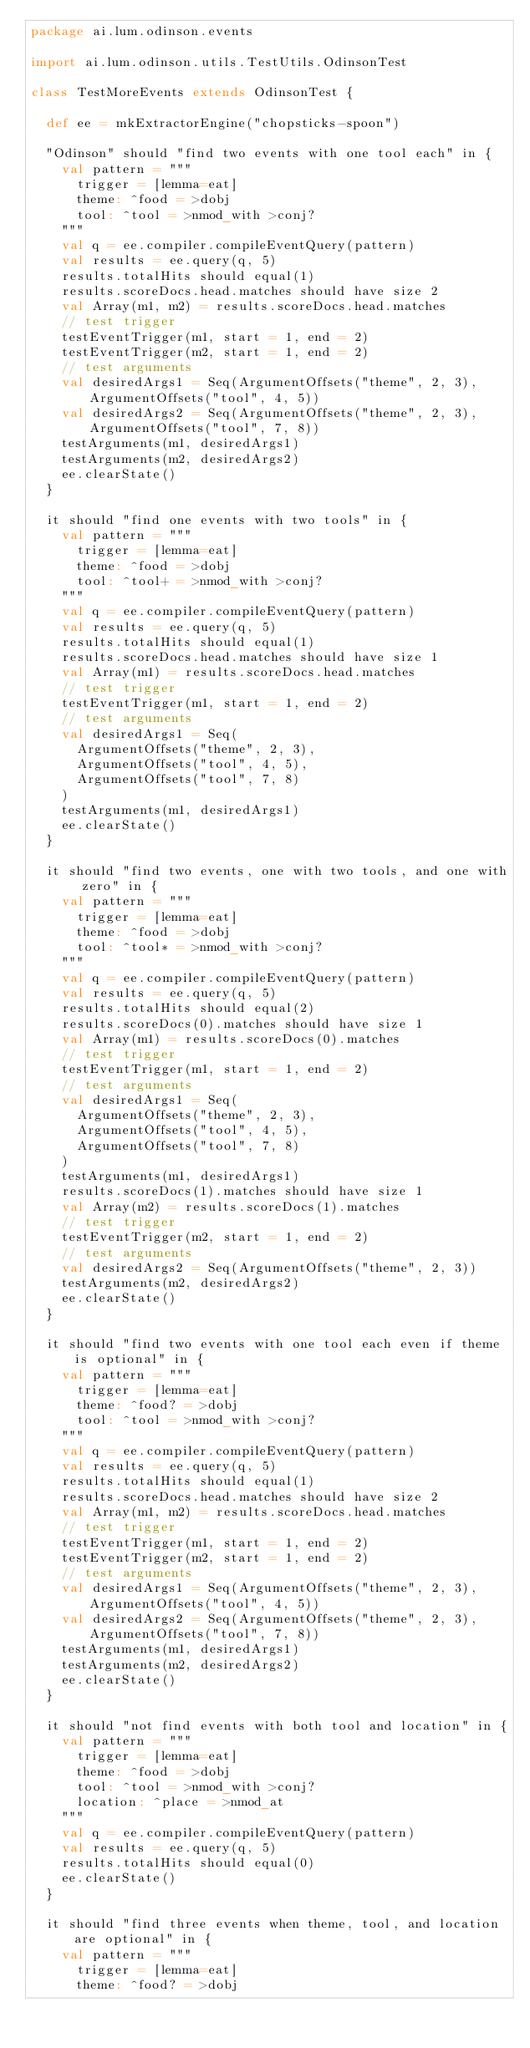<code> <loc_0><loc_0><loc_500><loc_500><_Scala_>package ai.lum.odinson.events

import ai.lum.odinson.utils.TestUtils.OdinsonTest

class TestMoreEvents extends OdinsonTest {

  def ee = mkExtractorEngine("chopsticks-spoon")

  "Odinson" should "find two events with one tool each" in {
    val pattern = """
      trigger = [lemma=eat]
      theme: ^food = >dobj
      tool: ^tool = >nmod_with >conj?
    """
    val q = ee.compiler.compileEventQuery(pattern)
    val results = ee.query(q, 5)
    results.totalHits should equal(1)
    results.scoreDocs.head.matches should have size 2
    val Array(m1, m2) = results.scoreDocs.head.matches
    // test trigger
    testEventTrigger(m1, start = 1, end = 2)
    testEventTrigger(m2, start = 1, end = 2)
    // test arguments
    val desiredArgs1 = Seq(ArgumentOffsets("theme", 2, 3), ArgumentOffsets("tool", 4, 5))
    val desiredArgs2 = Seq(ArgumentOffsets("theme", 2, 3), ArgumentOffsets("tool", 7, 8))
    testArguments(m1, desiredArgs1)
    testArguments(m2, desiredArgs2)
    ee.clearState()
  }

  it should "find one events with two tools" in {
    val pattern = """
      trigger = [lemma=eat]
      theme: ^food = >dobj
      tool: ^tool+ = >nmod_with >conj?
    """
    val q = ee.compiler.compileEventQuery(pattern)
    val results = ee.query(q, 5)
    results.totalHits should equal(1)
    results.scoreDocs.head.matches should have size 1
    val Array(m1) = results.scoreDocs.head.matches
    // test trigger
    testEventTrigger(m1, start = 1, end = 2)
    // test arguments
    val desiredArgs1 = Seq(
      ArgumentOffsets("theme", 2, 3),
      ArgumentOffsets("tool", 4, 5),
      ArgumentOffsets("tool", 7, 8)
    )
    testArguments(m1, desiredArgs1)
    ee.clearState()
  }

  it should "find two events, one with two tools, and one with zero" in {
    val pattern = """
      trigger = [lemma=eat]
      theme: ^food = >dobj
      tool: ^tool* = >nmod_with >conj?
    """
    val q = ee.compiler.compileEventQuery(pattern)
    val results = ee.query(q, 5)
    results.totalHits should equal(2)
    results.scoreDocs(0).matches should have size 1
    val Array(m1) = results.scoreDocs(0).matches
    // test trigger
    testEventTrigger(m1, start = 1, end = 2)
    // test arguments
    val desiredArgs1 = Seq(
      ArgumentOffsets("theme", 2, 3),
      ArgumentOffsets("tool", 4, 5),
      ArgumentOffsets("tool", 7, 8)
    )
    testArguments(m1, desiredArgs1)
    results.scoreDocs(1).matches should have size 1
    val Array(m2) = results.scoreDocs(1).matches
    // test trigger
    testEventTrigger(m2, start = 1, end = 2)
    // test arguments
    val desiredArgs2 = Seq(ArgumentOffsets("theme", 2, 3))
    testArguments(m2, desiredArgs2)
    ee.clearState()
  }

  it should "find two events with one tool each even if theme is optional" in {
    val pattern = """
      trigger = [lemma=eat]
      theme: ^food? = >dobj
      tool: ^tool = >nmod_with >conj?
    """
    val q = ee.compiler.compileEventQuery(pattern)
    val results = ee.query(q, 5)
    results.totalHits should equal(1)
    results.scoreDocs.head.matches should have size 2
    val Array(m1, m2) = results.scoreDocs.head.matches
    // test trigger
    testEventTrigger(m1, start = 1, end = 2)
    testEventTrigger(m2, start = 1, end = 2)
    // test arguments
    val desiredArgs1 = Seq(ArgumentOffsets("theme", 2, 3), ArgumentOffsets("tool", 4, 5))
    val desiredArgs2 = Seq(ArgumentOffsets("theme", 2, 3), ArgumentOffsets("tool", 7, 8))
    testArguments(m1, desiredArgs1)
    testArguments(m2, desiredArgs2)
    ee.clearState()
  }

  it should "not find events with both tool and location" in {
    val pattern = """
      trigger = [lemma=eat]
      theme: ^food = >dobj
      tool: ^tool = >nmod_with >conj?
      location: ^place = >nmod_at
    """
    val q = ee.compiler.compileEventQuery(pattern)
    val results = ee.query(q, 5)
    results.totalHits should equal(0)
    ee.clearState()
  }

  it should "find three events when theme, tool, and location are optional" in {
    val pattern = """
      trigger = [lemma=eat]
      theme: ^food? = >dobj</code> 